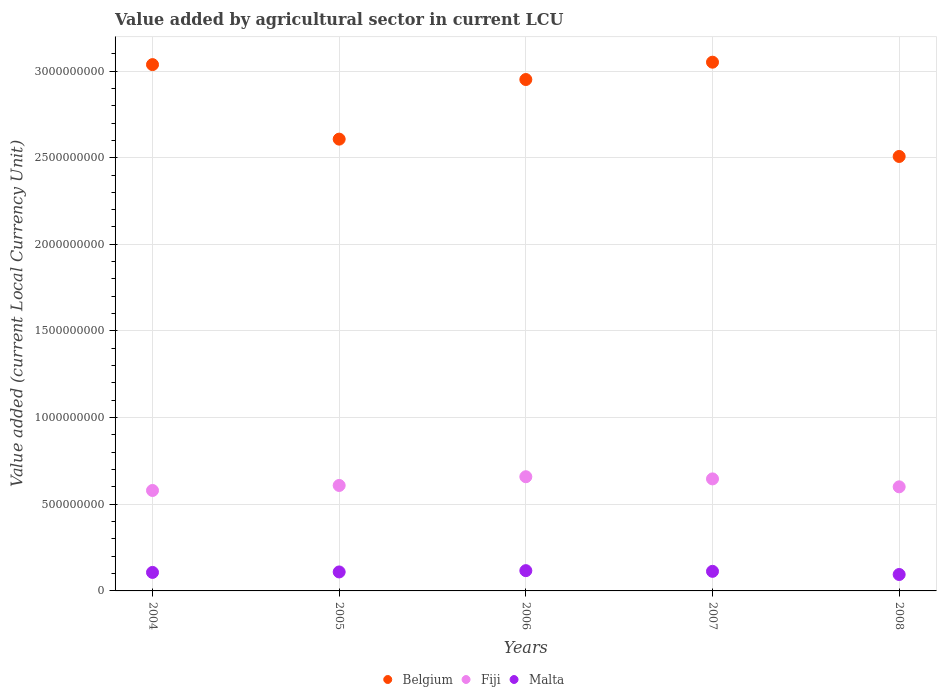How many different coloured dotlines are there?
Give a very brief answer. 3. What is the value added by agricultural sector in Fiji in 2006?
Your answer should be compact. 6.59e+08. Across all years, what is the maximum value added by agricultural sector in Belgium?
Provide a short and direct response. 3.05e+09. Across all years, what is the minimum value added by agricultural sector in Fiji?
Your answer should be very brief. 5.80e+08. In which year was the value added by agricultural sector in Belgium maximum?
Offer a terse response. 2007. In which year was the value added by agricultural sector in Belgium minimum?
Give a very brief answer. 2008. What is the total value added by agricultural sector in Malta in the graph?
Your answer should be compact. 5.41e+08. What is the difference between the value added by agricultural sector in Fiji in 2004 and that in 2005?
Provide a succinct answer. -2.90e+07. What is the difference between the value added by agricultural sector in Fiji in 2005 and the value added by agricultural sector in Malta in 2008?
Your answer should be very brief. 5.14e+08. What is the average value added by agricultural sector in Fiji per year?
Offer a terse response. 6.19e+08. In the year 2004, what is the difference between the value added by agricultural sector in Malta and value added by agricultural sector in Fiji?
Provide a short and direct response. -4.73e+08. What is the ratio of the value added by agricultural sector in Malta in 2005 to that in 2006?
Offer a terse response. 0.94. Is the value added by agricultural sector in Malta in 2005 less than that in 2007?
Keep it short and to the point. Yes. What is the difference between the highest and the second highest value added by agricultural sector in Fiji?
Keep it short and to the point. 1.25e+07. What is the difference between the highest and the lowest value added by agricultural sector in Belgium?
Your answer should be very brief. 5.44e+08. Is the sum of the value added by agricultural sector in Belgium in 2005 and 2006 greater than the maximum value added by agricultural sector in Malta across all years?
Give a very brief answer. Yes. Is the value added by agricultural sector in Belgium strictly greater than the value added by agricultural sector in Fiji over the years?
Give a very brief answer. Yes. How many dotlines are there?
Make the answer very short. 3. How many years are there in the graph?
Your answer should be very brief. 5. What is the difference between two consecutive major ticks on the Y-axis?
Provide a succinct answer. 5.00e+08. Are the values on the major ticks of Y-axis written in scientific E-notation?
Your answer should be very brief. No. Does the graph contain any zero values?
Give a very brief answer. No. What is the title of the graph?
Your answer should be compact. Value added by agricultural sector in current LCU. Does "South Africa" appear as one of the legend labels in the graph?
Give a very brief answer. No. What is the label or title of the Y-axis?
Make the answer very short. Value added (current Local Currency Unit). What is the Value added (current Local Currency Unit) of Belgium in 2004?
Your answer should be compact. 3.04e+09. What is the Value added (current Local Currency Unit) of Fiji in 2004?
Offer a terse response. 5.80e+08. What is the Value added (current Local Currency Unit) of Malta in 2004?
Provide a short and direct response. 1.07e+08. What is the Value added (current Local Currency Unit) of Belgium in 2005?
Your answer should be very brief. 2.61e+09. What is the Value added (current Local Currency Unit) of Fiji in 2005?
Your answer should be compact. 6.09e+08. What is the Value added (current Local Currency Unit) in Malta in 2005?
Offer a terse response. 1.10e+08. What is the Value added (current Local Currency Unit) in Belgium in 2006?
Your response must be concise. 2.95e+09. What is the Value added (current Local Currency Unit) in Fiji in 2006?
Offer a very short reply. 6.59e+08. What is the Value added (current Local Currency Unit) in Malta in 2006?
Offer a very short reply. 1.17e+08. What is the Value added (current Local Currency Unit) of Belgium in 2007?
Provide a short and direct response. 3.05e+09. What is the Value added (current Local Currency Unit) of Fiji in 2007?
Keep it short and to the point. 6.46e+08. What is the Value added (current Local Currency Unit) of Malta in 2007?
Your answer should be compact. 1.13e+08. What is the Value added (current Local Currency Unit) in Belgium in 2008?
Ensure brevity in your answer.  2.51e+09. What is the Value added (current Local Currency Unit) in Fiji in 2008?
Ensure brevity in your answer.  6.01e+08. What is the Value added (current Local Currency Unit) in Malta in 2008?
Ensure brevity in your answer.  9.48e+07. Across all years, what is the maximum Value added (current Local Currency Unit) of Belgium?
Offer a very short reply. 3.05e+09. Across all years, what is the maximum Value added (current Local Currency Unit) in Fiji?
Give a very brief answer. 6.59e+08. Across all years, what is the maximum Value added (current Local Currency Unit) in Malta?
Give a very brief answer. 1.17e+08. Across all years, what is the minimum Value added (current Local Currency Unit) of Belgium?
Your answer should be very brief. 2.51e+09. Across all years, what is the minimum Value added (current Local Currency Unit) of Fiji?
Give a very brief answer. 5.80e+08. Across all years, what is the minimum Value added (current Local Currency Unit) of Malta?
Your answer should be very brief. 9.48e+07. What is the total Value added (current Local Currency Unit) in Belgium in the graph?
Keep it short and to the point. 1.42e+1. What is the total Value added (current Local Currency Unit) in Fiji in the graph?
Your response must be concise. 3.09e+09. What is the total Value added (current Local Currency Unit) in Malta in the graph?
Provide a succinct answer. 5.41e+08. What is the difference between the Value added (current Local Currency Unit) of Belgium in 2004 and that in 2005?
Your response must be concise. 4.30e+08. What is the difference between the Value added (current Local Currency Unit) in Fiji in 2004 and that in 2005?
Your answer should be very brief. -2.90e+07. What is the difference between the Value added (current Local Currency Unit) of Malta in 2004 and that in 2005?
Provide a succinct answer. -2.70e+06. What is the difference between the Value added (current Local Currency Unit) in Belgium in 2004 and that in 2006?
Your response must be concise. 8.60e+07. What is the difference between the Value added (current Local Currency Unit) in Fiji in 2004 and that in 2006?
Your answer should be compact. -7.93e+07. What is the difference between the Value added (current Local Currency Unit) of Malta in 2004 and that in 2006?
Your response must be concise. -1.02e+07. What is the difference between the Value added (current Local Currency Unit) of Belgium in 2004 and that in 2007?
Provide a succinct answer. -1.40e+07. What is the difference between the Value added (current Local Currency Unit) of Fiji in 2004 and that in 2007?
Your response must be concise. -6.68e+07. What is the difference between the Value added (current Local Currency Unit) of Malta in 2004 and that in 2007?
Your answer should be very brief. -6.20e+06. What is the difference between the Value added (current Local Currency Unit) of Belgium in 2004 and that in 2008?
Your answer should be very brief. 5.30e+08. What is the difference between the Value added (current Local Currency Unit) in Fiji in 2004 and that in 2008?
Ensure brevity in your answer.  -2.11e+07. What is the difference between the Value added (current Local Currency Unit) of Malta in 2004 and that in 2008?
Provide a short and direct response. 1.20e+07. What is the difference between the Value added (current Local Currency Unit) of Belgium in 2005 and that in 2006?
Provide a short and direct response. -3.44e+08. What is the difference between the Value added (current Local Currency Unit) in Fiji in 2005 and that in 2006?
Provide a short and direct response. -5.04e+07. What is the difference between the Value added (current Local Currency Unit) in Malta in 2005 and that in 2006?
Provide a short and direct response. -7.50e+06. What is the difference between the Value added (current Local Currency Unit) in Belgium in 2005 and that in 2007?
Provide a succinct answer. -4.44e+08. What is the difference between the Value added (current Local Currency Unit) of Fiji in 2005 and that in 2007?
Make the answer very short. -3.79e+07. What is the difference between the Value added (current Local Currency Unit) in Malta in 2005 and that in 2007?
Keep it short and to the point. -3.50e+06. What is the difference between the Value added (current Local Currency Unit) in Fiji in 2005 and that in 2008?
Provide a short and direct response. 7.89e+06. What is the difference between the Value added (current Local Currency Unit) of Malta in 2005 and that in 2008?
Your response must be concise. 1.47e+07. What is the difference between the Value added (current Local Currency Unit) of Belgium in 2006 and that in 2007?
Provide a succinct answer. -1.00e+08. What is the difference between the Value added (current Local Currency Unit) of Fiji in 2006 and that in 2007?
Ensure brevity in your answer.  1.25e+07. What is the difference between the Value added (current Local Currency Unit) of Belgium in 2006 and that in 2008?
Offer a very short reply. 4.44e+08. What is the difference between the Value added (current Local Currency Unit) in Fiji in 2006 and that in 2008?
Ensure brevity in your answer.  5.83e+07. What is the difference between the Value added (current Local Currency Unit) in Malta in 2006 and that in 2008?
Offer a terse response. 2.22e+07. What is the difference between the Value added (current Local Currency Unit) in Belgium in 2007 and that in 2008?
Offer a very short reply. 5.44e+08. What is the difference between the Value added (current Local Currency Unit) of Fiji in 2007 and that in 2008?
Offer a very short reply. 4.58e+07. What is the difference between the Value added (current Local Currency Unit) in Malta in 2007 and that in 2008?
Your response must be concise. 1.82e+07. What is the difference between the Value added (current Local Currency Unit) of Belgium in 2004 and the Value added (current Local Currency Unit) of Fiji in 2005?
Your answer should be compact. 2.43e+09. What is the difference between the Value added (current Local Currency Unit) of Belgium in 2004 and the Value added (current Local Currency Unit) of Malta in 2005?
Provide a short and direct response. 2.93e+09. What is the difference between the Value added (current Local Currency Unit) in Fiji in 2004 and the Value added (current Local Currency Unit) in Malta in 2005?
Provide a short and direct response. 4.70e+08. What is the difference between the Value added (current Local Currency Unit) of Belgium in 2004 and the Value added (current Local Currency Unit) of Fiji in 2006?
Provide a short and direct response. 2.38e+09. What is the difference between the Value added (current Local Currency Unit) in Belgium in 2004 and the Value added (current Local Currency Unit) in Malta in 2006?
Your answer should be very brief. 2.92e+09. What is the difference between the Value added (current Local Currency Unit) in Fiji in 2004 and the Value added (current Local Currency Unit) in Malta in 2006?
Offer a very short reply. 4.63e+08. What is the difference between the Value added (current Local Currency Unit) in Belgium in 2004 and the Value added (current Local Currency Unit) in Fiji in 2007?
Provide a succinct answer. 2.39e+09. What is the difference between the Value added (current Local Currency Unit) of Belgium in 2004 and the Value added (current Local Currency Unit) of Malta in 2007?
Provide a short and direct response. 2.92e+09. What is the difference between the Value added (current Local Currency Unit) of Fiji in 2004 and the Value added (current Local Currency Unit) of Malta in 2007?
Ensure brevity in your answer.  4.67e+08. What is the difference between the Value added (current Local Currency Unit) in Belgium in 2004 and the Value added (current Local Currency Unit) in Fiji in 2008?
Ensure brevity in your answer.  2.44e+09. What is the difference between the Value added (current Local Currency Unit) in Belgium in 2004 and the Value added (current Local Currency Unit) in Malta in 2008?
Your response must be concise. 2.94e+09. What is the difference between the Value added (current Local Currency Unit) of Fiji in 2004 and the Value added (current Local Currency Unit) of Malta in 2008?
Provide a succinct answer. 4.85e+08. What is the difference between the Value added (current Local Currency Unit) in Belgium in 2005 and the Value added (current Local Currency Unit) in Fiji in 2006?
Offer a terse response. 1.95e+09. What is the difference between the Value added (current Local Currency Unit) in Belgium in 2005 and the Value added (current Local Currency Unit) in Malta in 2006?
Make the answer very short. 2.49e+09. What is the difference between the Value added (current Local Currency Unit) of Fiji in 2005 and the Value added (current Local Currency Unit) of Malta in 2006?
Your answer should be compact. 4.92e+08. What is the difference between the Value added (current Local Currency Unit) in Belgium in 2005 and the Value added (current Local Currency Unit) in Fiji in 2007?
Keep it short and to the point. 1.96e+09. What is the difference between the Value added (current Local Currency Unit) in Belgium in 2005 and the Value added (current Local Currency Unit) in Malta in 2007?
Your response must be concise. 2.49e+09. What is the difference between the Value added (current Local Currency Unit) in Fiji in 2005 and the Value added (current Local Currency Unit) in Malta in 2007?
Your answer should be compact. 4.96e+08. What is the difference between the Value added (current Local Currency Unit) in Belgium in 2005 and the Value added (current Local Currency Unit) in Fiji in 2008?
Offer a very short reply. 2.01e+09. What is the difference between the Value added (current Local Currency Unit) of Belgium in 2005 and the Value added (current Local Currency Unit) of Malta in 2008?
Give a very brief answer. 2.51e+09. What is the difference between the Value added (current Local Currency Unit) of Fiji in 2005 and the Value added (current Local Currency Unit) of Malta in 2008?
Keep it short and to the point. 5.14e+08. What is the difference between the Value added (current Local Currency Unit) in Belgium in 2006 and the Value added (current Local Currency Unit) in Fiji in 2007?
Your answer should be compact. 2.30e+09. What is the difference between the Value added (current Local Currency Unit) in Belgium in 2006 and the Value added (current Local Currency Unit) in Malta in 2007?
Your answer should be very brief. 2.84e+09. What is the difference between the Value added (current Local Currency Unit) in Fiji in 2006 and the Value added (current Local Currency Unit) in Malta in 2007?
Provide a short and direct response. 5.46e+08. What is the difference between the Value added (current Local Currency Unit) of Belgium in 2006 and the Value added (current Local Currency Unit) of Fiji in 2008?
Offer a terse response. 2.35e+09. What is the difference between the Value added (current Local Currency Unit) in Belgium in 2006 and the Value added (current Local Currency Unit) in Malta in 2008?
Your answer should be compact. 2.86e+09. What is the difference between the Value added (current Local Currency Unit) of Fiji in 2006 and the Value added (current Local Currency Unit) of Malta in 2008?
Keep it short and to the point. 5.64e+08. What is the difference between the Value added (current Local Currency Unit) of Belgium in 2007 and the Value added (current Local Currency Unit) of Fiji in 2008?
Offer a very short reply. 2.45e+09. What is the difference between the Value added (current Local Currency Unit) in Belgium in 2007 and the Value added (current Local Currency Unit) in Malta in 2008?
Give a very brief answer. 2.96e+09. What is the difference between the Value added (current Local Currency Unit) of Fiji in 2007 and the Value added (current Local Currency Unit) of Malta in 2008?
Ensure brevity in your answer.  5.52e+08. What is the average Value added (current Local Currency Unit) in Belgium per year?
Keep it short and to the point. 2.83e+09. What is the average Value added (current Local Currency Unit) of Fiji per year?
Provide a succinct answer. 6.19e+08. What is the average Value added (current Local Currency Unit) of Malta per year?
Ensure brevity in your answer.  1.08e+08. In the year 2004, what is the difference between the Value added (current Local Currency Unit) in Belgium and Value added (current Local Currency Unit) in Fiji?
Your response must be concise. 2.46e+09. In the year 2004, what is the difference between the Value added (current Local Currency Unit) of Belgium and Value added (current Local Currency Unit) of Malta?
Keep it short and to the point. 2.93e+09. In the year 2004, what is the difference between the Value added (current Local Currency Unit) of Fiji and Value added (current Local Currency Unit) of Malta?
Your answer should be very brief. 4.73e+08. In the year 2005, what is the difference between the Value added (current Local Currency Unit) in Belgium and Value added (current Local Currency Unit) in Fiji?
Offer a terse response. 2.00e+09. In the year 2005, what is the difference between the Value added (current Local Currency Unit) of Belgium and Value added (current Local Currency Unit) of Malta?
Offer a very short reply. 2.50e+09. In the year 2005, what is the difference between the Value added (current Local Currency Unit) of Fiji and Value added (current Local Currency Unit) of Malta?
Your response must be concise. 4.99e+08. In the year 2006, what is the difference between the Value added (current Local Currency Unit) of Belgium and Value added (current Local Currency Unit) of Fiji?
Provide a succinct answer. 2.29e+09. In the year 2006, what is the difference between the Value added (current Local Currency Unit) of Belgium and Value added (current Local Currency Unit) of Malta?
Ensure brevity in your answer.  2.83e+09. In the year 2006, what is the difference between the Value added (current Local Currency Unit) in Fiji and Value added (current Local Currency Unit) in Malta?
Give a very brief answer. 5.42e+08. In the year 2007, what is the difference between the Value added (current Local Currency Unit) of Belgium and Value added (current Local Currency Unit) of Fiji?
Give a very brief answer. 2.40e+09. In the year 2007, what is the difference between the Value added (current Local Currency Unit) in Belgium and Value added (current Local Currency Unit) in Malta?
Offer a very short reply. 2.94e+09. In the year 2007, what is the difference between the Value added (current Local Currency Unit) in Fiji and Value added (current Local Currency Unit) in Malta?
Provide a succinct answer. 5.33e+08. In the year 2008, what is the difference between the Value added (current Local Currency Unit) in Belgium and Value added (current Local Currency Unit) in Fiji?
Provide a short and direct response. 1.91e+09. In the year 2008, what is the difference between the Value added (current Local Currency Unit) in Belgium and Value added (current Local Currency Unit) in Malta?
Ensure brevity in your answer.  2.41e+09. In the year 2008, what is the difference between the Value added (current Local Currency Unit) of Fiji and Value added (current Local Currency Unit) of Malta?
Offer a terse response. 5.06e+08. What is the ratio of the Value added (current Local Currency Unit) in Belgium in 2004 to that in 2005?
Offer a terse response. 1.16. What is the ratio of the Value added (current Local Currency Unit) in Malta in 2004 to that in 2005?
Provide a succinct answer. 0.98. What is the ratio of the Value added (current Local Currency Unit) in Belgium in 2004 to that in 2006?
Offer a terse response. 1.03. What is the ratio of the Value added (current Local Currency Unit) in Fiji in 2004 to that in 2006?
Ensure brevity in your answer.  0.88. What is the ratio of the Value added (current Local Currency Unit) of Malta in 2004 to that in 2006?
Provide a short and direct response. 0.91. What is the ratio of the Value added (current Local Currency Unit) in Fiji in 2004 to that in 2007?
Give a very brief answer. 0.9. What is the ratio of the Value added (current Local Currency Unit) of Malta in 2004 to that in 2007?
Your response must be concise. 0.95. What is the ratio of the Value added (current Local Currency Unit) in Belgium in 2004 to that in 2008?
Keep it short and to the point. 1.21. What is the ratio of the Value added (current Local Currency Unit) of Fiji in 2004 to that in 2008?
Keep it short and to the point. 0.96. What is the ratio of the Value added (current Local Currency Unit) in Malta in 2004 to that in 2008?
Offer a terse response. 1.13. What is the ratio of the Value added (current Local Currency Unit) in Belgium in 2005 to that in 2006?
Provide a succinct answer. 0.88. What is the ratio of the Value added (current Local Currency Unit) in Fiji in 2005 to that in 2006?
Offer a very short reply. 0.92. What is the ratio of the Value added (current Local Currency Unit) in Malta in 2005 to that in 2006?
Your answer should be compact. 0.94. What is the ratio of the Value added (current Local Currency Unit) of Belgium in 2005 to that in 2007?
Ensure brevity in your answer.  0.85. What is the ratio of the Value added (current Local Currency Unit) of Fiji in 2005 to that in 2007?
Offer a terse response. 0.94. What is the ratio of the Value added (current Local Currency Unit) in Belgium in 2005 to that in 2008?
Your response must be concise. 1.04. What is the ratio of the Value added (current Local Currency Unit) of Fiji in 2005 to that in 2008?
Your answer should be compact. 1.01. What is the ratio of the Value added (current Local Currency Unit) of Malta in 2005 to that in 2008?
Make the answer very short. 1.16. What is the ratio of the Value added (current Local Currency Unit) in Belgium in 2006 to that in 2007?
Give a very brief answer. 0.97. What is the ratio of the Value added (current Local Currency Unit) in Fiji in 2006 to that in 2007?
Provide a short and direct response. 1.02. What is the ratio of the Value added (current Local Currency Unit) in Malta in 2006 to that in 2007?
Provide a short and direct response. 1.04. What is the ratio of the Value added (current Local Currency Unit) of Belgium in 2006 to that in 2008?
Provide a short and direct response. 1.18. What is the ratio of the Value added (current Local Currency Unit) in Fiji in 2006 to that in 2008?
Give a very brief answer. 1.1. What is the ratio of the Value added (current Local Currency Unit) in Malta in 2006 to that in 2008?
Your answer should be compact. 1.23. What is the ratio of the Value added (current Local Currency Unit) in Belgium in 2007 to that in 2008?
Your answer should be very brief. 1.22. What is the ratio of the Value added (current Local Currency Unit) of Fiji in 2007 to that in 2008?
Give a very brief answer. 1.08. What is the ratio of the Value added (current Local Currency Unit) in Malta in 2007 to that in 2008?
Make the answer very short. 1.19. What is the difference between the highest and the second highest Value added (current Local Currency Unit) in Belgium?
Make the answer very short. 1.40e+07. What is the difference between the highest and the second highest Value added (current Local Currency Unit) of Fiji?
Ensure brevity in your answer.  1.25e+07. What is the difference between the highest and the second highest Value added (current Local Currency Unit) in Malta?
Your answer should be compact. 4.00e+06. What is the difference between the highest and the lowest Value added (current Local Currency Unit) in Belgium?
Your response must be concise. 5.44e+08. What is the difference between the highest and the lowest Value added (current Local Currency Unit) in Fiji?
Make the answer very short. 7.93e+07. What is the difference between the highest and the lowest Value added (current Local Currency Unit) of Malta?
Your response must be concise. 2.22e+07. 